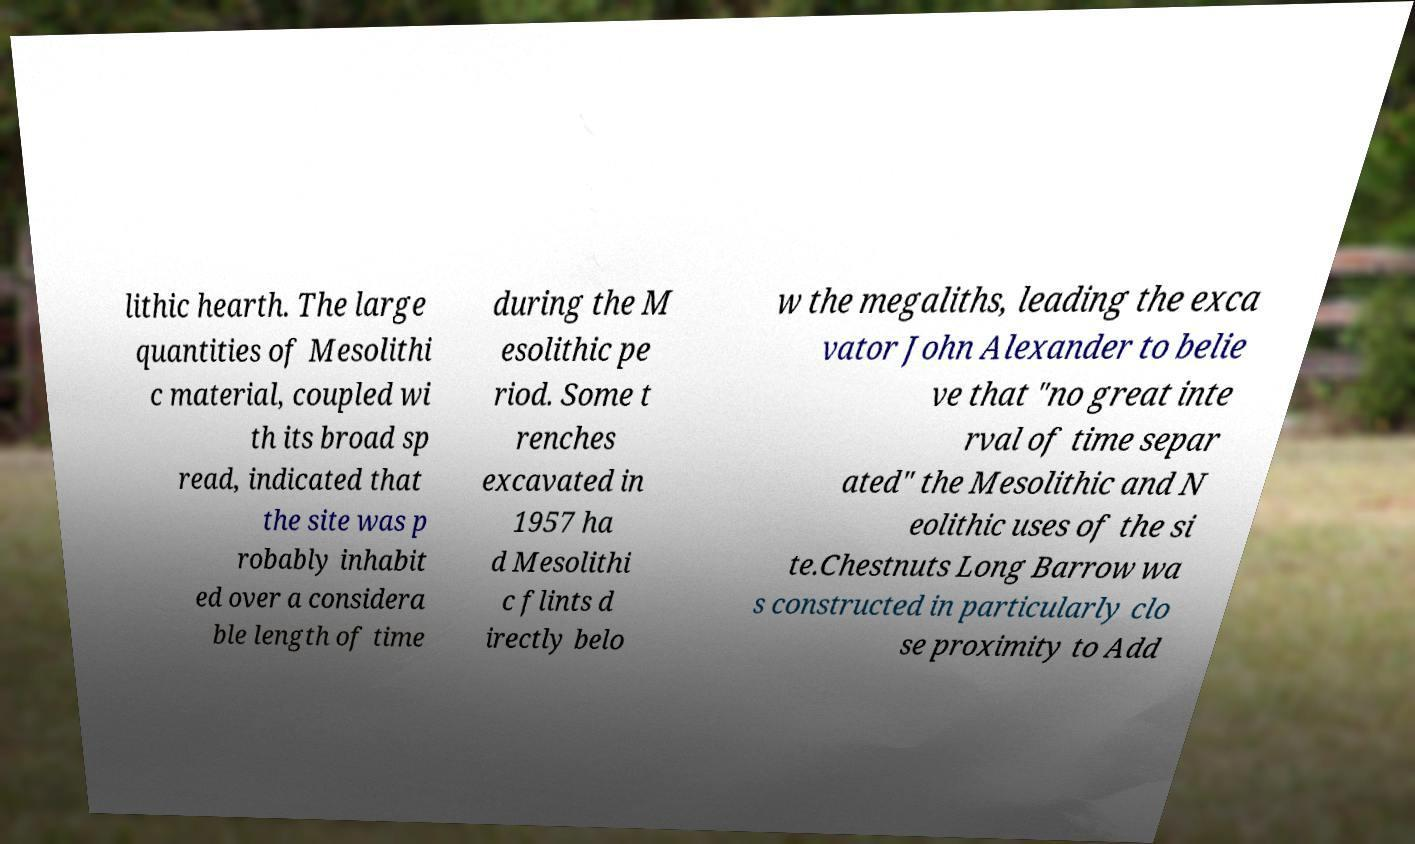Could you assist in decoding the text presented in this image and type it out clearly? lithic hearth. The large quantities of Mesolithi c material, coupled wi th its broad sp read, indicated that the site was p robably inhabit ed over a considera ble length of time during the M esolithic pe riod. Some t renches excavated in 1957 ha d Mesolithi c flints d irectly belo w the megaliths, leading the exca vator John Alexander to belie ve that "no great inte rval of time separ ated" the Mesolithic and N eolithic uses of the si te.Chestnuts Long Barrow wa s constructed in particularly clo se proximity to Add 